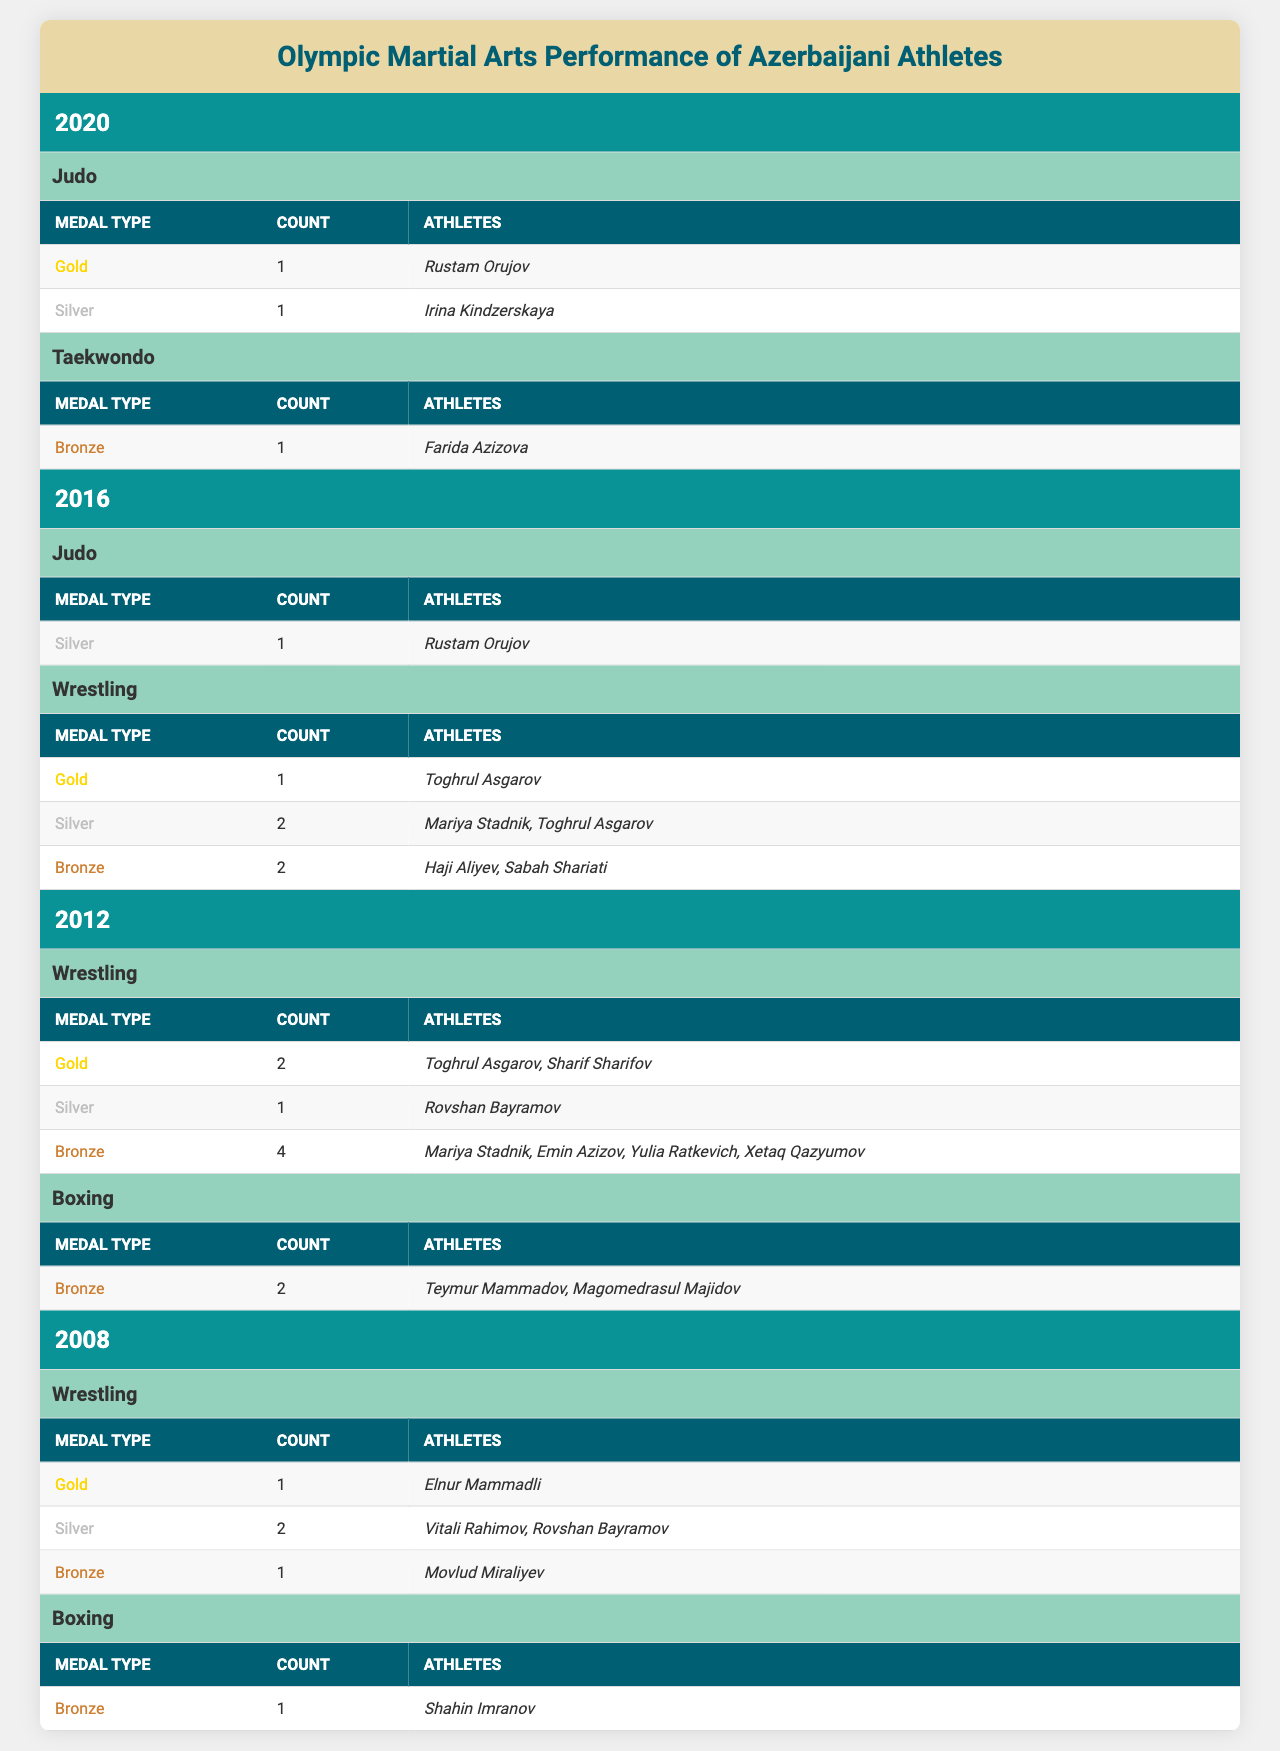What is the total number of gold medals won by Azerbaijani athletes across all years? In 2020, there is 1 gold medal in Judo; in 2016, 1 gold medal in Wrestling; in 2012, there are 2 gold medals in Wrestling; and in 2008, there is 1 gold medal in Wrestling. Adding these up gives us 1 + 1 + 2 + 1 = 5 gold medals.
Answer: 5 Which sport awarded the most silver medals to Azerbaijani athletes? In 2016, Wrestling awarded 2 silvers; in 2008, there were 2 silvers as well. Other years had fewer silvers in other sports. Therefore, Wrestling in both years had the most silver medals, totaling to 2.
Answer: Wrestling Who is the only athlete to win a gold medal in the Olympic Judo event for Azerbaijan? The table shows that Rustam Orujov is the only athlete listed under the gold medals for Judo in 2020.
Answer: Rustam Orujov How many bronze medals were won in total by Azerbaijani athletes in the year 2012? In 2012, Wrestling had 4 bronze medals and Boxing had 2 bronze medals. Summing these gives us 4 + 2 = 6 bronze medals for that year.
Answer: 6 Was there any year where Azerbaijani athletes did not win any medals in Taekwondo? Looking through all the years listed, 2012, 2016, and 2008 did not mention Taekwondo. Only in 2020 was there 1 bronze medal in Taekwondo. Thus, yes, there are years with no Taekwondo medals.
Answer: Yes How does the total count of medals in 2016 compare to 2020? In 2016, the total medals were 1 silver (Judo) + 1 gold + 2 silvers + 2 bronzes = 6 medals. In 2020, the total medals were 1 gold + 1 silver + 1 bronze = 3 medals. This shows that 2016 had more total medals than 2020.
Answer: 2016 had more medals Which athlete has the most bronze medals and in which years did they earn them? Mariya Stadnik earned 4 bronze medals in 2012 and 2 in 2016 from Wrestling, totaling 6. Other athletes have fewer bronze medals.
Answer: Mariya Stadnik, in 2012 and 2016 What sport had the highest total medal count across all years in this table? Wrestling has a higher total than other sports: 1 gold + 2 silver + 2 bronze in 2016, 2 gold + 1 silver + 4 bronze in 2012, and 1 gold + 2 silver + 1 bronze in 2008, summing to 12 medals. Boxing and Judo had significantly fewer medals.
Answer: Wrestling Did any athlete win medals in both Judo and Wrestling? Checking the data, Rustam Orujov won a silver in Judo in 2016 and a gold in Wrestling in 2020. Thus, yes, he won medals in both sports.
Answer: Yes How many athletes won medals in boxing during the 2012 Olympics? In 2012, there were 2 athletes listed with bronze medals in Boxing.
Answer: 2 Which year had the highest diversity of medal types and how many types? In 2012, 3 types of medals were awarded in Wrestling (gold, silver, bronze) and Boxing (bronze), totaling 4 types. No other year had such diversity and quantity of types of medals across different sports.
Answer: 2012, 4 types 